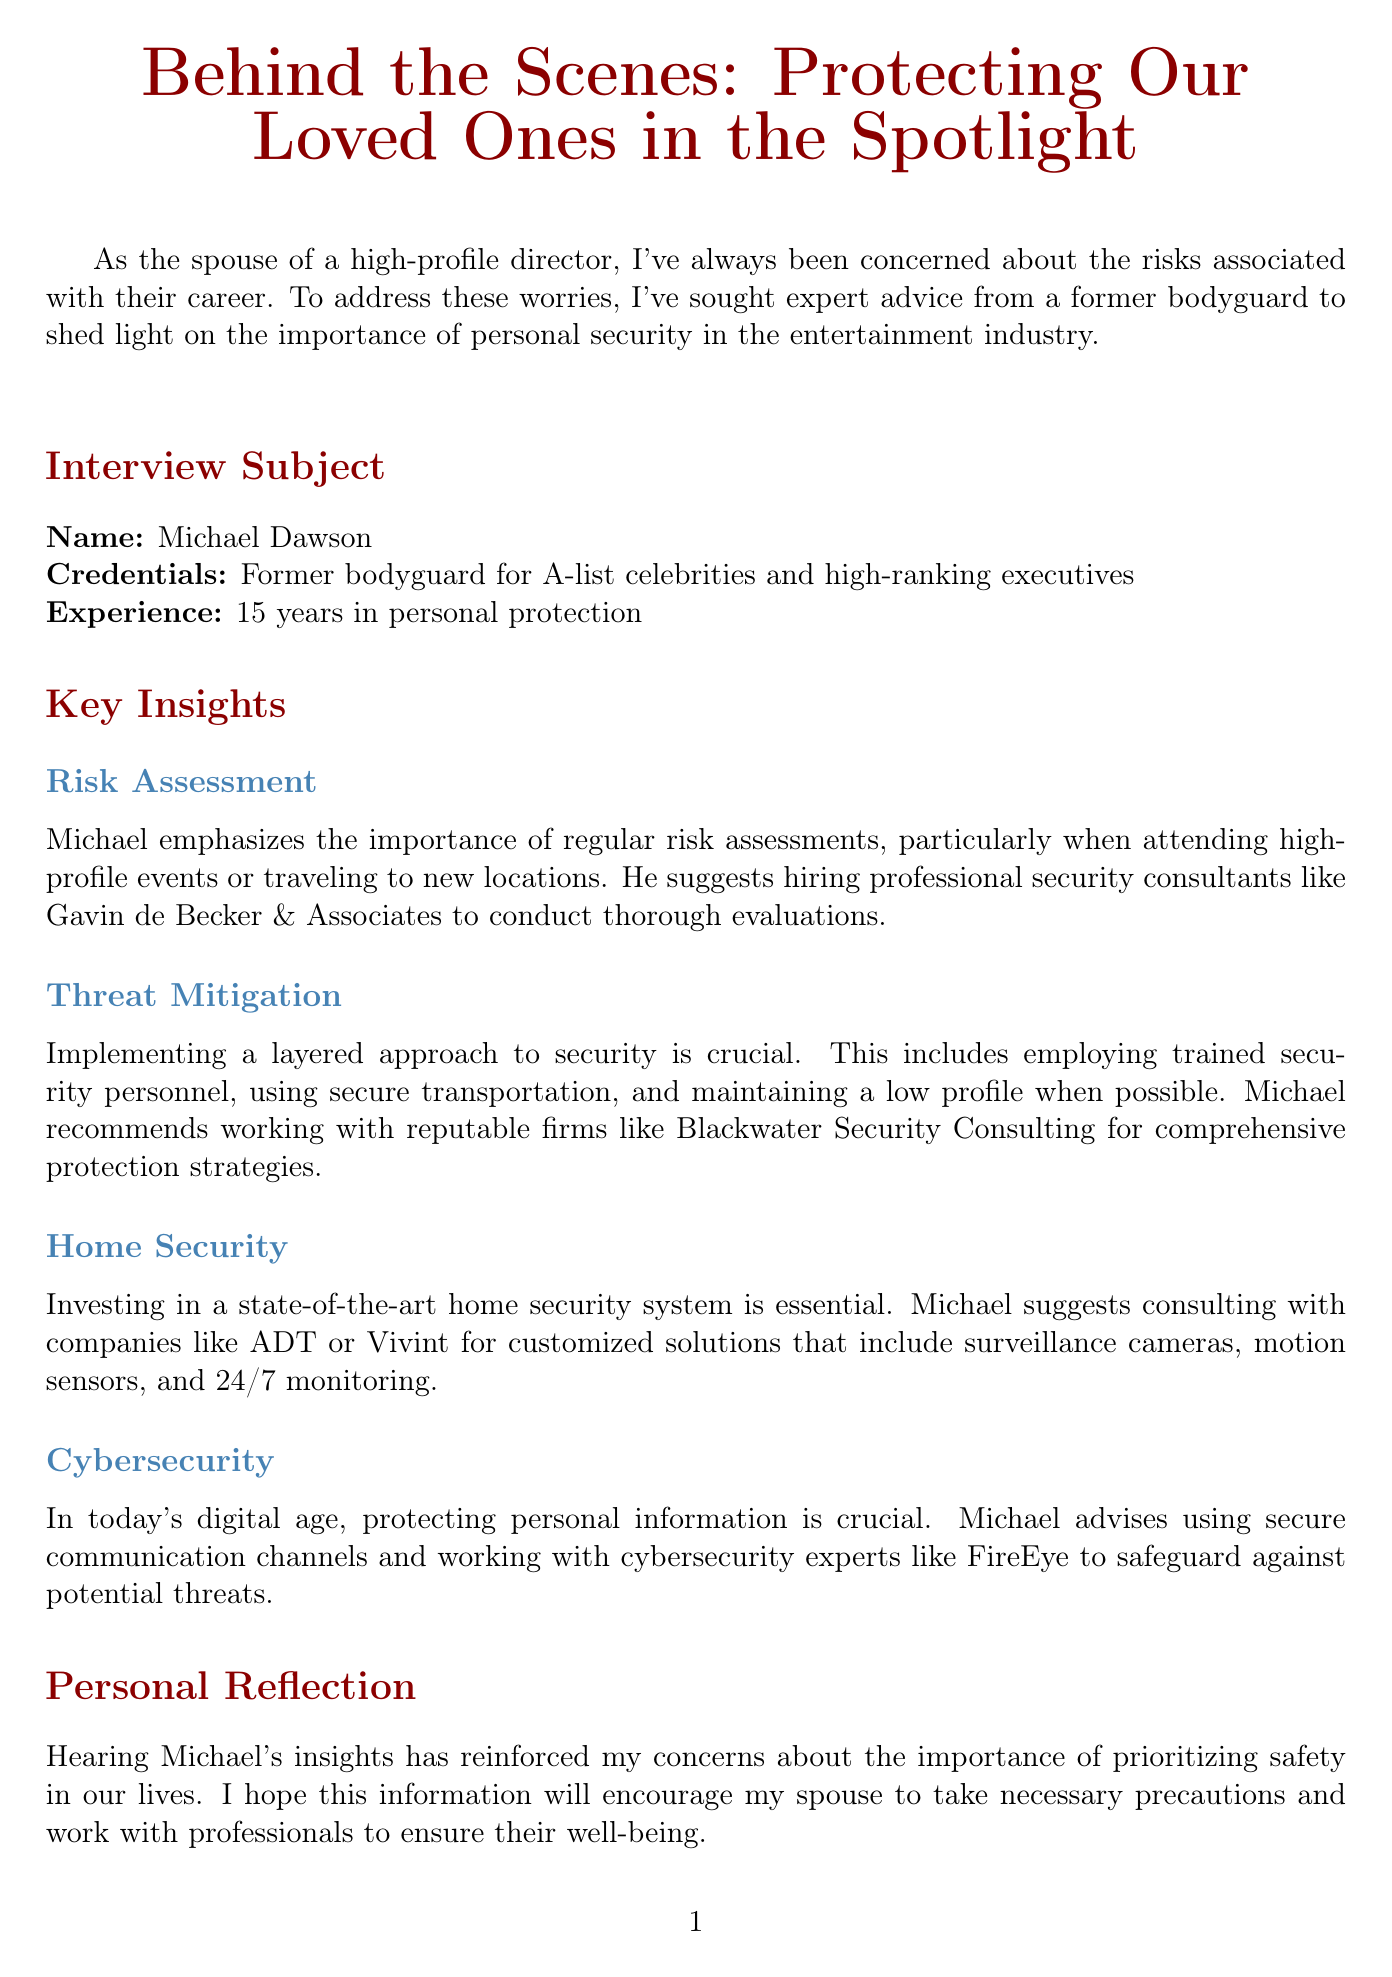What is the title of the newsletter? The title is prominently displayed at the top of the document, emphasizing the focus on safety and protection.
Answer: Behind the Scenes: Protecting Our Loved Ones in the Spotlight Who is the interview subject? The document includes a section specifically identifying the subject of the interview.
Answer: Michael Dawson What is Michael Dawson's experience in personal protection? The document states his years of experience, highlighting his background and credibility.
Answer: 15 years What is one of the recommended companies for risk assessment? The document mentions a specific company that Michael recommends for conducting thorough evaluations.
Answer: Gavin de Becker & Associates What is a suggested action item for the family? The document lists specific steps to enhance safety and security that the family should undertake.
Answer: Schedule a family meeting to discuss security concerns Why is a state-of-the-art home security system important? This information is found in the home security section explaining its relevance in personal safety.
Answer: Essential What does Michael recommend for cybersecurity? The cybersecurity section includes expert advice on safeguarding personal information.
Answer: FireEye How many key insights are shared in the newsletter? The document categorizes the information into distinct topics of discussion providing a numerical overview.
Answer: Four 